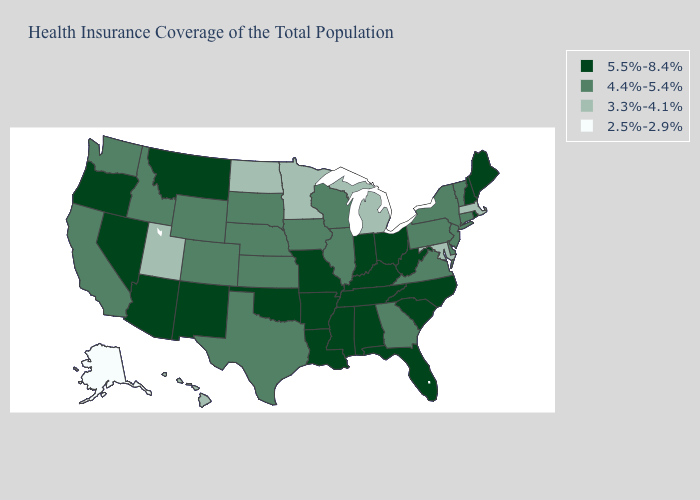How many symbols are there in the legend?
Give a very brief answer. 4. What is the highest value in states that border Montana?
Give a very brief answer. 4.4%-5.4%. What is the value of Montana?
Short answer required. 5.5%-8.4%. Does New Mexico have the same value as Wyoming?
Write a very short answer. No. What is the highest value in the USA?
Concise answer only. 5.5%-8.4%. Name the states that have a value in the range 3.3%-4.1%?
Write a very short answer. Hawaii, Maryland, Massachusetts, Michigan, Minnesota, North Dakota, Utah. What is the value of South Dakota?
Short answer required. 4.4%-5.4%. Does New Hampshire have the highest value in the USA?
Answer briefly. Yes. Among the states that border Florida , which have the highest value?
Keep it brief. Alabama. Does Florida have the lowest value in the USA?
Write a very short answer. No. Name the states that have a value in the range 4.4%-5.4%?
Give a very brief answer. California, Colorado, Connecticut, Delaware, Georgia, Idaho, Illinois, Iowa, Kansas, Nebraska, New Jersey, New York, Pennsylvania, South Dakota, Texas, Vermont, Virginia, Washington, Wisconsin, Wyoming. Name the states that have a value in the range 2.5%-2.9%?
Be succinct. Alaska. What is the value of Mississippi?
Answer briefly. 5.5%-8.4%. Among the states that border Massachusetts , does Vermont have the lowest value?
Give a very brief answer. Yes. What is the value of Montana?
Keep it brief. 5.5%-8.4%. 